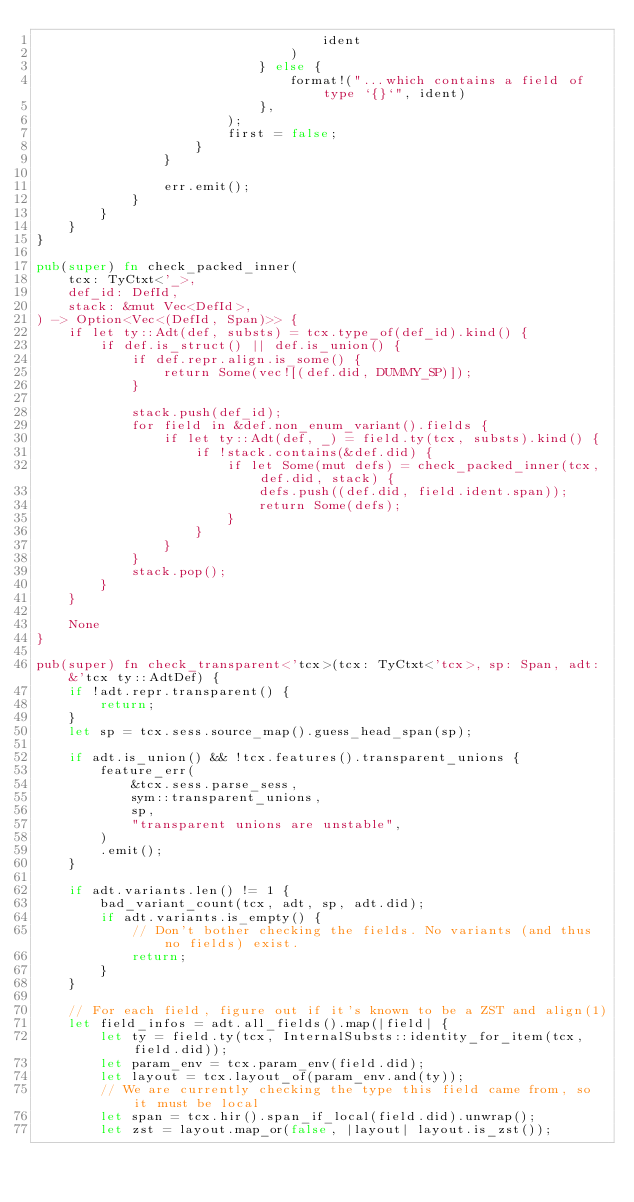<code> <loc_0><loc_0><loc_500><loc_500><_Rust_>                                    ident
                                )
                            } else {
                                format!("...which contains a field of type `{}`", ident)
                            },
                        );
                        first = false;
                    }
                }

                err.emit();
            }
        }
    }
}

pub(super) fn check_packed_inner(
    tcx: TyCtxt<'_>,
    def_id: DefId,
    stack: &mut Vec<DefId>,
) -> Option<Vec<(DefId, Span)>> {
    if let ty::Adt(def, substs) = tcx.type_of(def_id).kind() {
        if def.is_struct() || def.is_union() {
            if def.repr.align.is_some() {
                return Some(vec![(def.did, DUMMY_SP)]);
            }

            stack.push(def_id);
            for field in &def.non_enum_variant().fields {
                if let ty::Adt(def, _) = field.ty(tcx, substs).kind() {
                    if !stack.contains(&def.did) {
                        if let Some(mut defs) = check_packed_inner(tcx, def.did, stack) {
                            defs.push((def.did, field.ident.span));
                            return Some(defs);
                        }
                    }
                }
            }
            stack.pop();
        }
    }

    None
}

pub(super) fn check_transparent<'tcx>(tcx: TyCtxt<'tcx>, sp: Span, adt: &'tcx ty::AdtDef) {
    if !adt.repr.transparent() {
        return;
    }
    let sp = tcx.sess.source_map().guess_head_span(sp);

    if adt.is_union() && !tcx.features().transparent_unions {
        feature_err(
            &tcx.sess.parse_sess,
            sym::transparent_unions,
            sp,
            "transparent unions are unstable",
        )
        .emit();
    }

    if adt.variants.len() != 1 {
        bad_variant_count(tcx, adt, sp, adt.did);
        if adt.variants.is_empty() {
            // Don't bother checking the fields. No variants (and thus no fields) exist.
            return;
        }
    }

    // For each field, figure out if it's known to be a ZST and align(1)
    let field_infos = adt.all_fields().map(|field| {
        let ty = field.ty(tcx, InternalSubsts::identity_for_item(tcx, field.did));
        let param_env = tcx.param_env(field.did);
        let layout = tcx.layout_of(param_env.and(ty));
        // We are currently checking the type this field came from, so it must be local
        let span = tcx.hir().span_if_local(field.did).unwrap();
        let zst = layout.map_or(false, |layout| layout.is_zst());</code> 